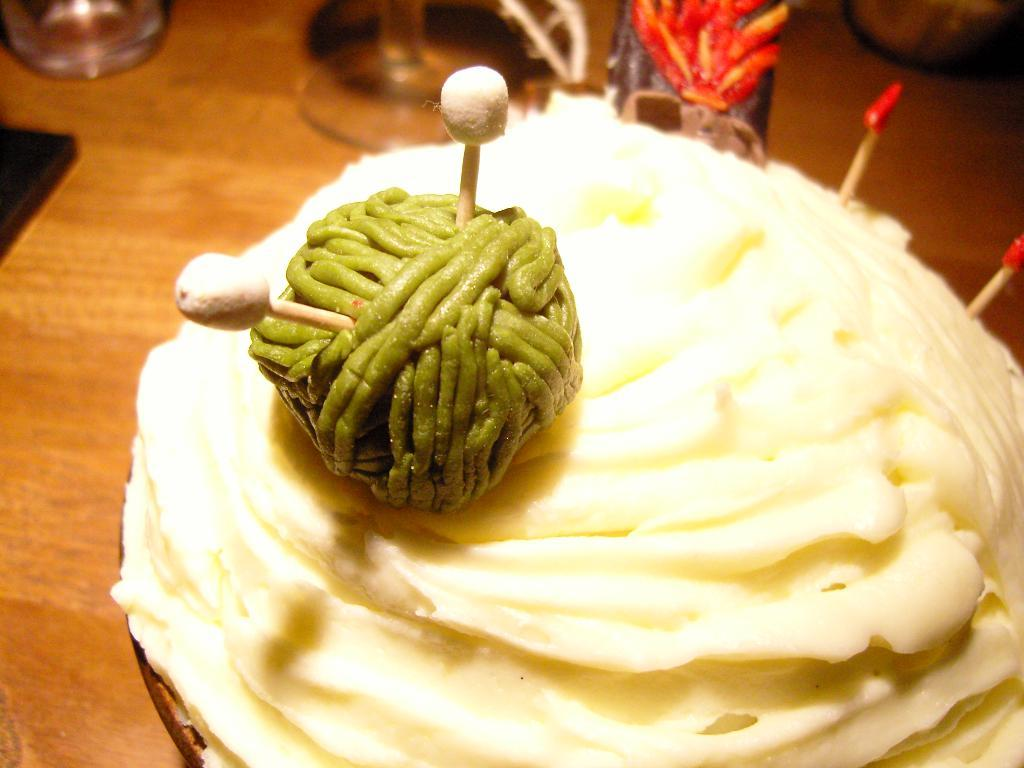What type of furniture is visible in the image? There is a table in the image. What can be seen in the foreground of the image? There is food in the foreground of the image. What is located in the background of the image? There are glasses in the background of the image. Can you describe any other objects present in the background of the image? There are other objects present in the background of the image, but their specific details are not mentioned in the provided facts. What type of mark can be seen on the throat of the person in the image? There is no person present in the image, and therefore no throat or mark can be observed. 